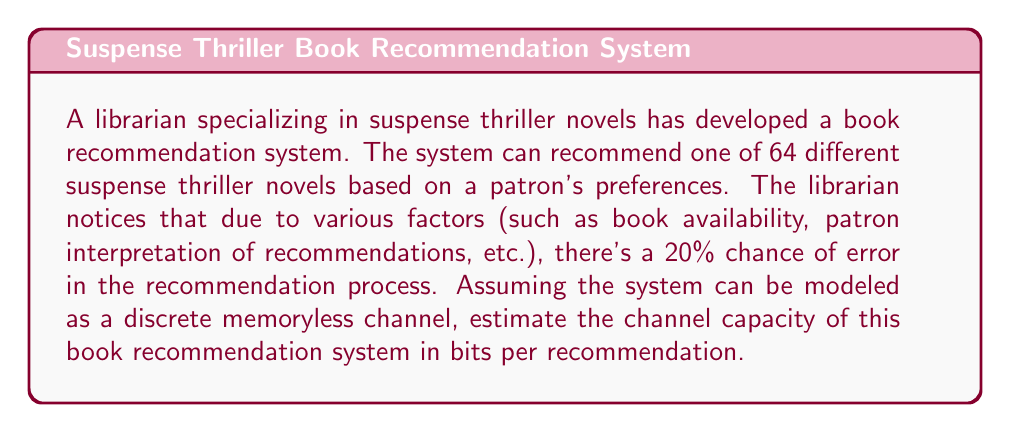What is the answer to this math problem? To solve this problem, we'll use the concept of channel capacity from information theory. Let's approach this step-by-step:

1) In this case, we have a discrete channel with 64 possible inputs (the books that can be recommended).

2) The channel capacity for a discrete memoryless channel is given by the formula:

   $$ C = \log_2 M - H(p) $$

   Where:
   - $C$ is the channel capacity in bits
   - $M$ is the number of possible inputs
   - $H(p)$ is the binary entropy function of the error probability $p$

3) We know that $M = 64$ and the error probability $p = 0.20$

4) First, let's calculate $\log_2 M$:

   $$ \log_2 64 = 6 \text{ bits} $$

5) Next, we need to calculate $H(p)$. The binary entropy function is defined as:

   $$ H(p) = -p \log_2 p - (1-p) \log_2 (1-p) $$

6) Substituting $p = 0.20$:

   $$ H(0.20) = -0.20 \log_2 0.20 - 0.80 \log_2 0.80 $$

7) Calculating this:

   $$ H(0.20) \approx 0.72 \text{ bits} $$

8) Now we can calculate the channel capacity:

   $$ C = 6 - 0.72 = 5.28 \text{ bits per recommendation} $$

Therefore, the estimated channel capacity of the librarian's book recommendation system is approximately 5.28 bits per recommendation.
Answer: $5.28 \text{ bits per recommendation}$ 